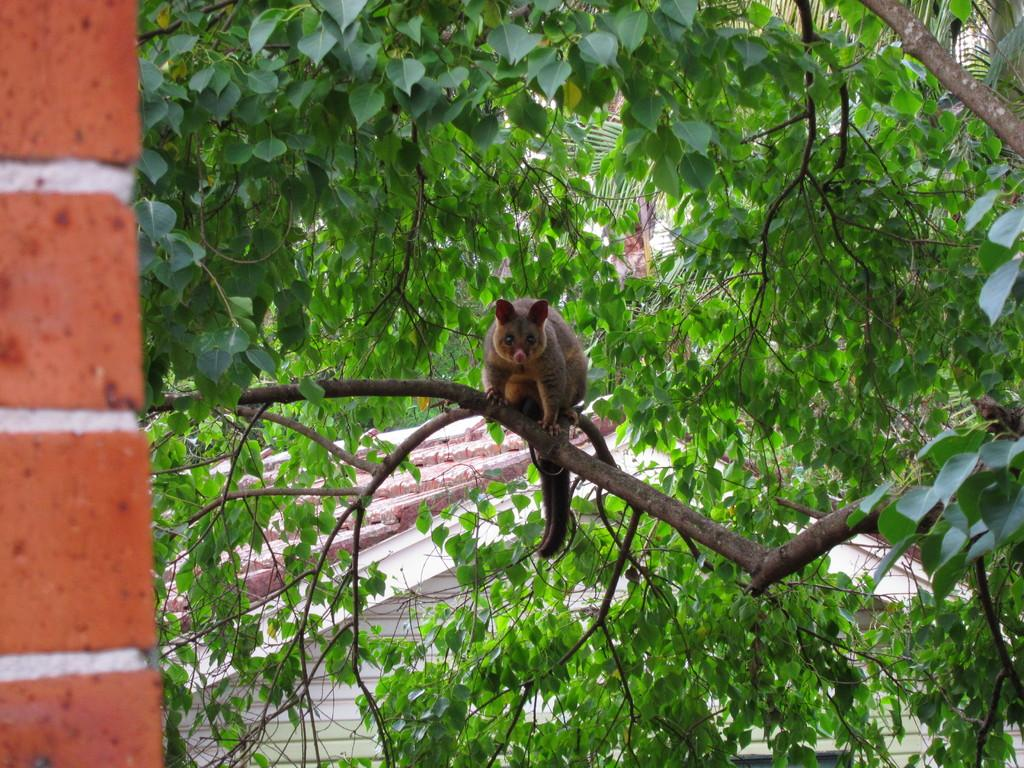What is located on the tree branch in the foreground of the image? There is a phalange on a tree branch in the foreground of the image. What can be seen on the left side of the image? There is a wall on the left side of the image. What structure is visible in the background of the image? There is a house in the background of the image. What type of worm can be seen crawling on the wall in the image? There is no worm present in the image; it features a phalange on a tree branch, a wall, and a house in the background. What advertisement is displayed on the house in the image? There is no advertisement present on the house in the image; it is simply a house in the background. 